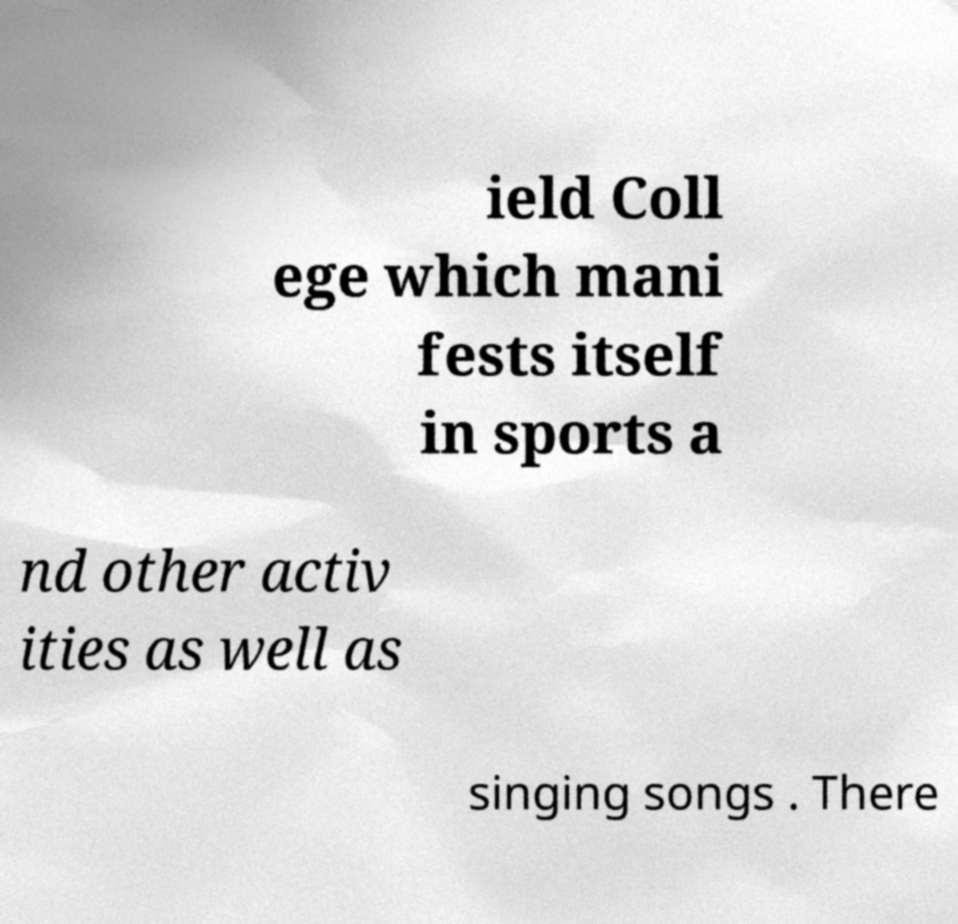I need the written content from this picture converted into text. Can you do that? ield Coll ege which mani fests itself in sports a nd other activ ities as well as singing songs . There 